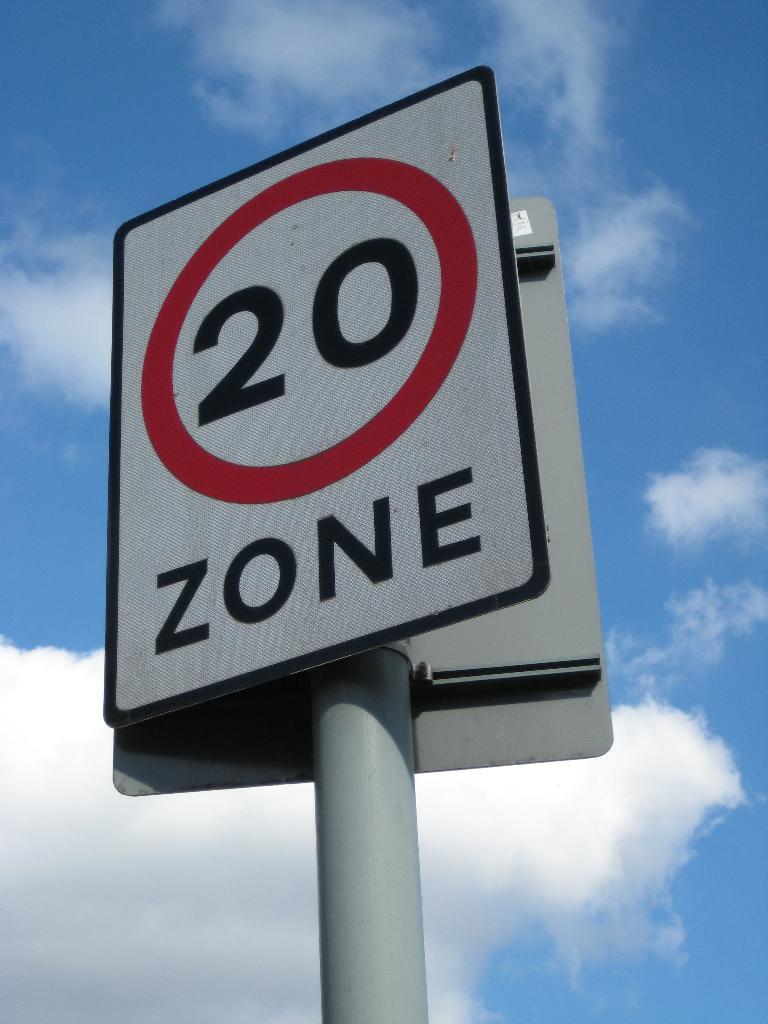Describe this image in one or two sentences. In this image we can see boards on a pole. In the background we can see clouds in the sky. 